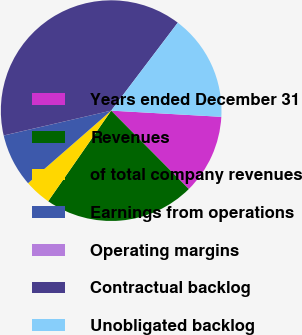<chart> <loc_0><loc_0><loc_500><loc_500><pie_chart><fcel>Years ended December 31<fcel>Revenues<fcel>of total company revenues<fcel>Earnings from operations<fcel>Operating margins<fcel>Contractual backlog<fcel>Unobligated backlog<nl><fcel>11.69%<fcel>22.09%<fcel>3.91%<fcel>7.8%<fcel>0.01%<fcel>38.93%<fcel>15.58%<nl></chart> 